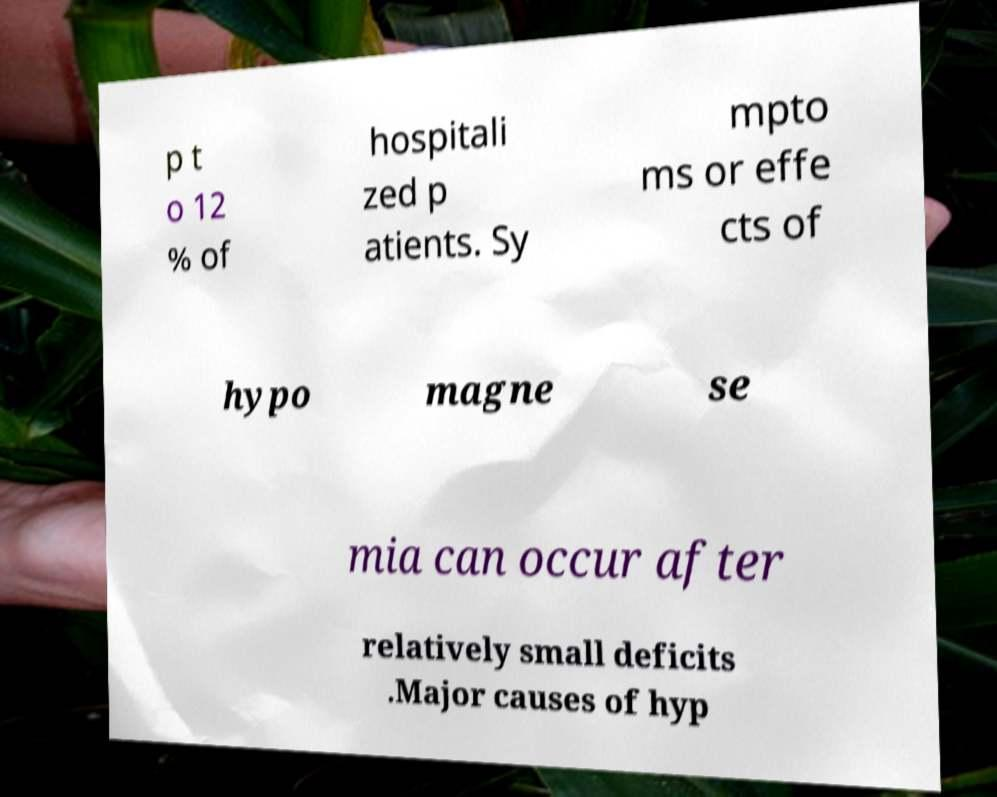Please read and relay the text visible in this image. What does it say? p t o 12 % of hospitali zed p atients. Sy mpto ms or effe cts of hypo magne se mia can occur after relatively small deficits .Major causes of hyp 